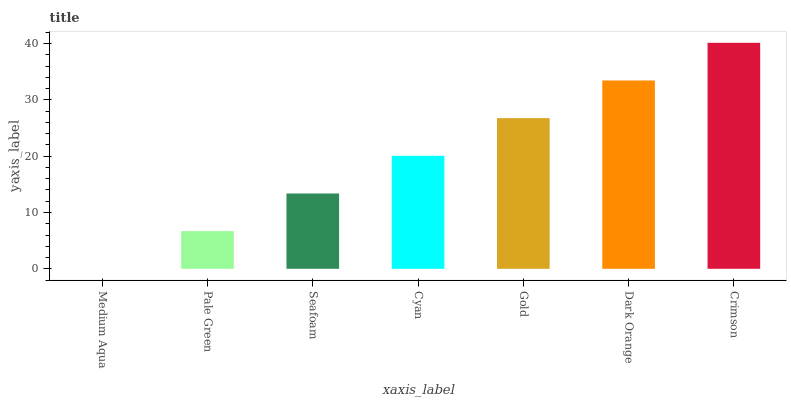Is Medium Aqua the minimum?
Answer yes or no. Yes. Is Crimson the maximum?
Answer yes or no. Yes. Is Pale Green the minimum?
Answer yes or no. No. Is Pale Green the maximum?
Answer yes or no. No. Is Pale Green greater than Medium Aqua?
Answer yes or no. Yes. Is Medium Aqua less than Pale Green?
Answer yes or no. Yes. Is Medium Aqua greater than Pale Green?
Answer yes or no. No. Is Pale Green less than Medium Aqua?
Answer yes or no. No. Is Cyan the high median?
Answer yes or no. Yes. Is Cyan the low median?
Answer yes or no. Yes. Is Seafoam the high median?
Answer yes or no. No. Is Medium Aqua the low median?
Answer yes or no. No. 